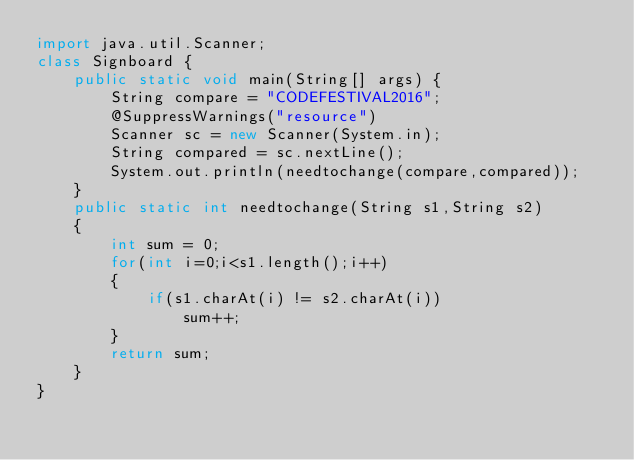Convert code to text. <code><loc_0><loc_0><loc_500><loc_500><_Java_>import java.util.Scanner;
class Signboard {
	public static void main(String[] args) {
		String compare = "CODEFESTIVAL2016";
		@SuppressWarnings("resource")
		Scanner sc = new Scanner(System.in);
		String compared = sc.nextLine();
		System.out.println(needtochange(compare,compared));
	}
	public static int needtochange(String s1,String s2)
	{
		int sum = 0;
		for(int i=0;i<s1.length();i++)
		{
			if(s1.charAt(i) != s2.charAt(i))
				sum++;
		}
		return sum;
	}
}
</code> 